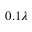Convert formula to latex. <formula><loc_0><loc_0><loc_500><loc_500>0 . 1 \lambda</formula> 